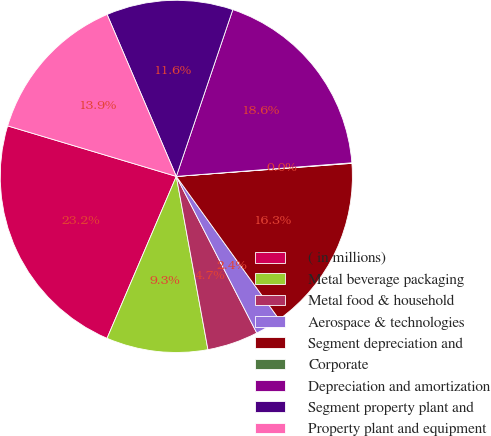<chart> <loc_0><loc_0><loc_500><loc_500><pie_chart><fcel>( in millions)<fcel>Metal beverage packaging<fcel>Metal food & household<fcel>Aerospace & technologies<fcel>Segment depreciation and<fcel>Corporate<fcel>Depreciation and amortization<fcel>Segment property plant and<fcel>Property plant and equipment<nl><fcel>23.2%<fcel>9.31%<fcel>4.68%<fcel>2.37%<fcel>16.26%<fcel>0.05%<fcel>18.57%<fcel>11.63%<fcel>13.94%<nl></chart> 